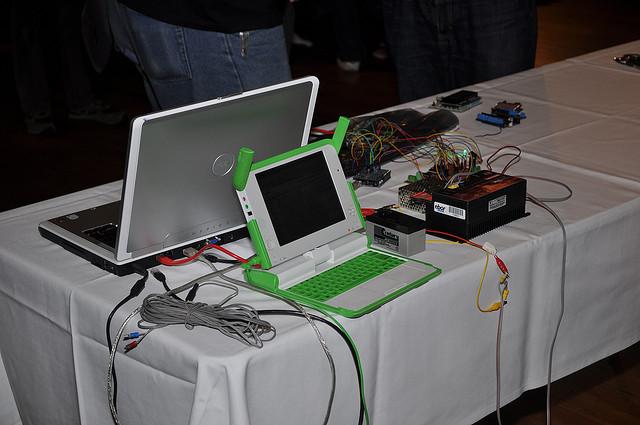Do you see any beverages?
Short answer required. No. Can this small screen play full movies?
Answer briefly. Yes. Is there a person in the picture?
Be succinct. Yes. Why are there wires?
Give a very brief answer. For power. 